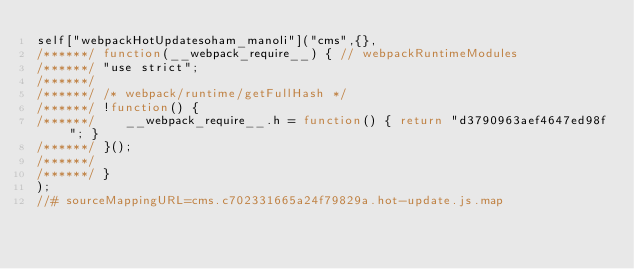Convert code to text. <code><loc_0><loc_0><loc_500><loc_500><_JavaScript_>self["webpackHotUpdatesoham_manoli"]("cms",{},
/******/ function(__webpack_require__) { // webpackRuntimeModules
/******/ "use strict";
/******/ 
/******/ /* webpack/runtime/getFullHash */
/******/ !function() {
/******/ 	__webpack_require__.h = function() { return "d3790963aef4647ed98f"; }
/******/ }();
/******/ 
/******/ }
);
//# sourceMappingURL=cms.c702331665a24f79829a.hot-update.js.map</code> 